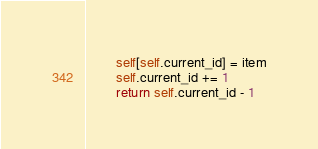Convert code to text. <code><loc_0><loc_0><loc_500><loc_500><_Python_>        self[self.current_id] = item
        self.current_id += 1
        return self.current_id - 1
</code> 